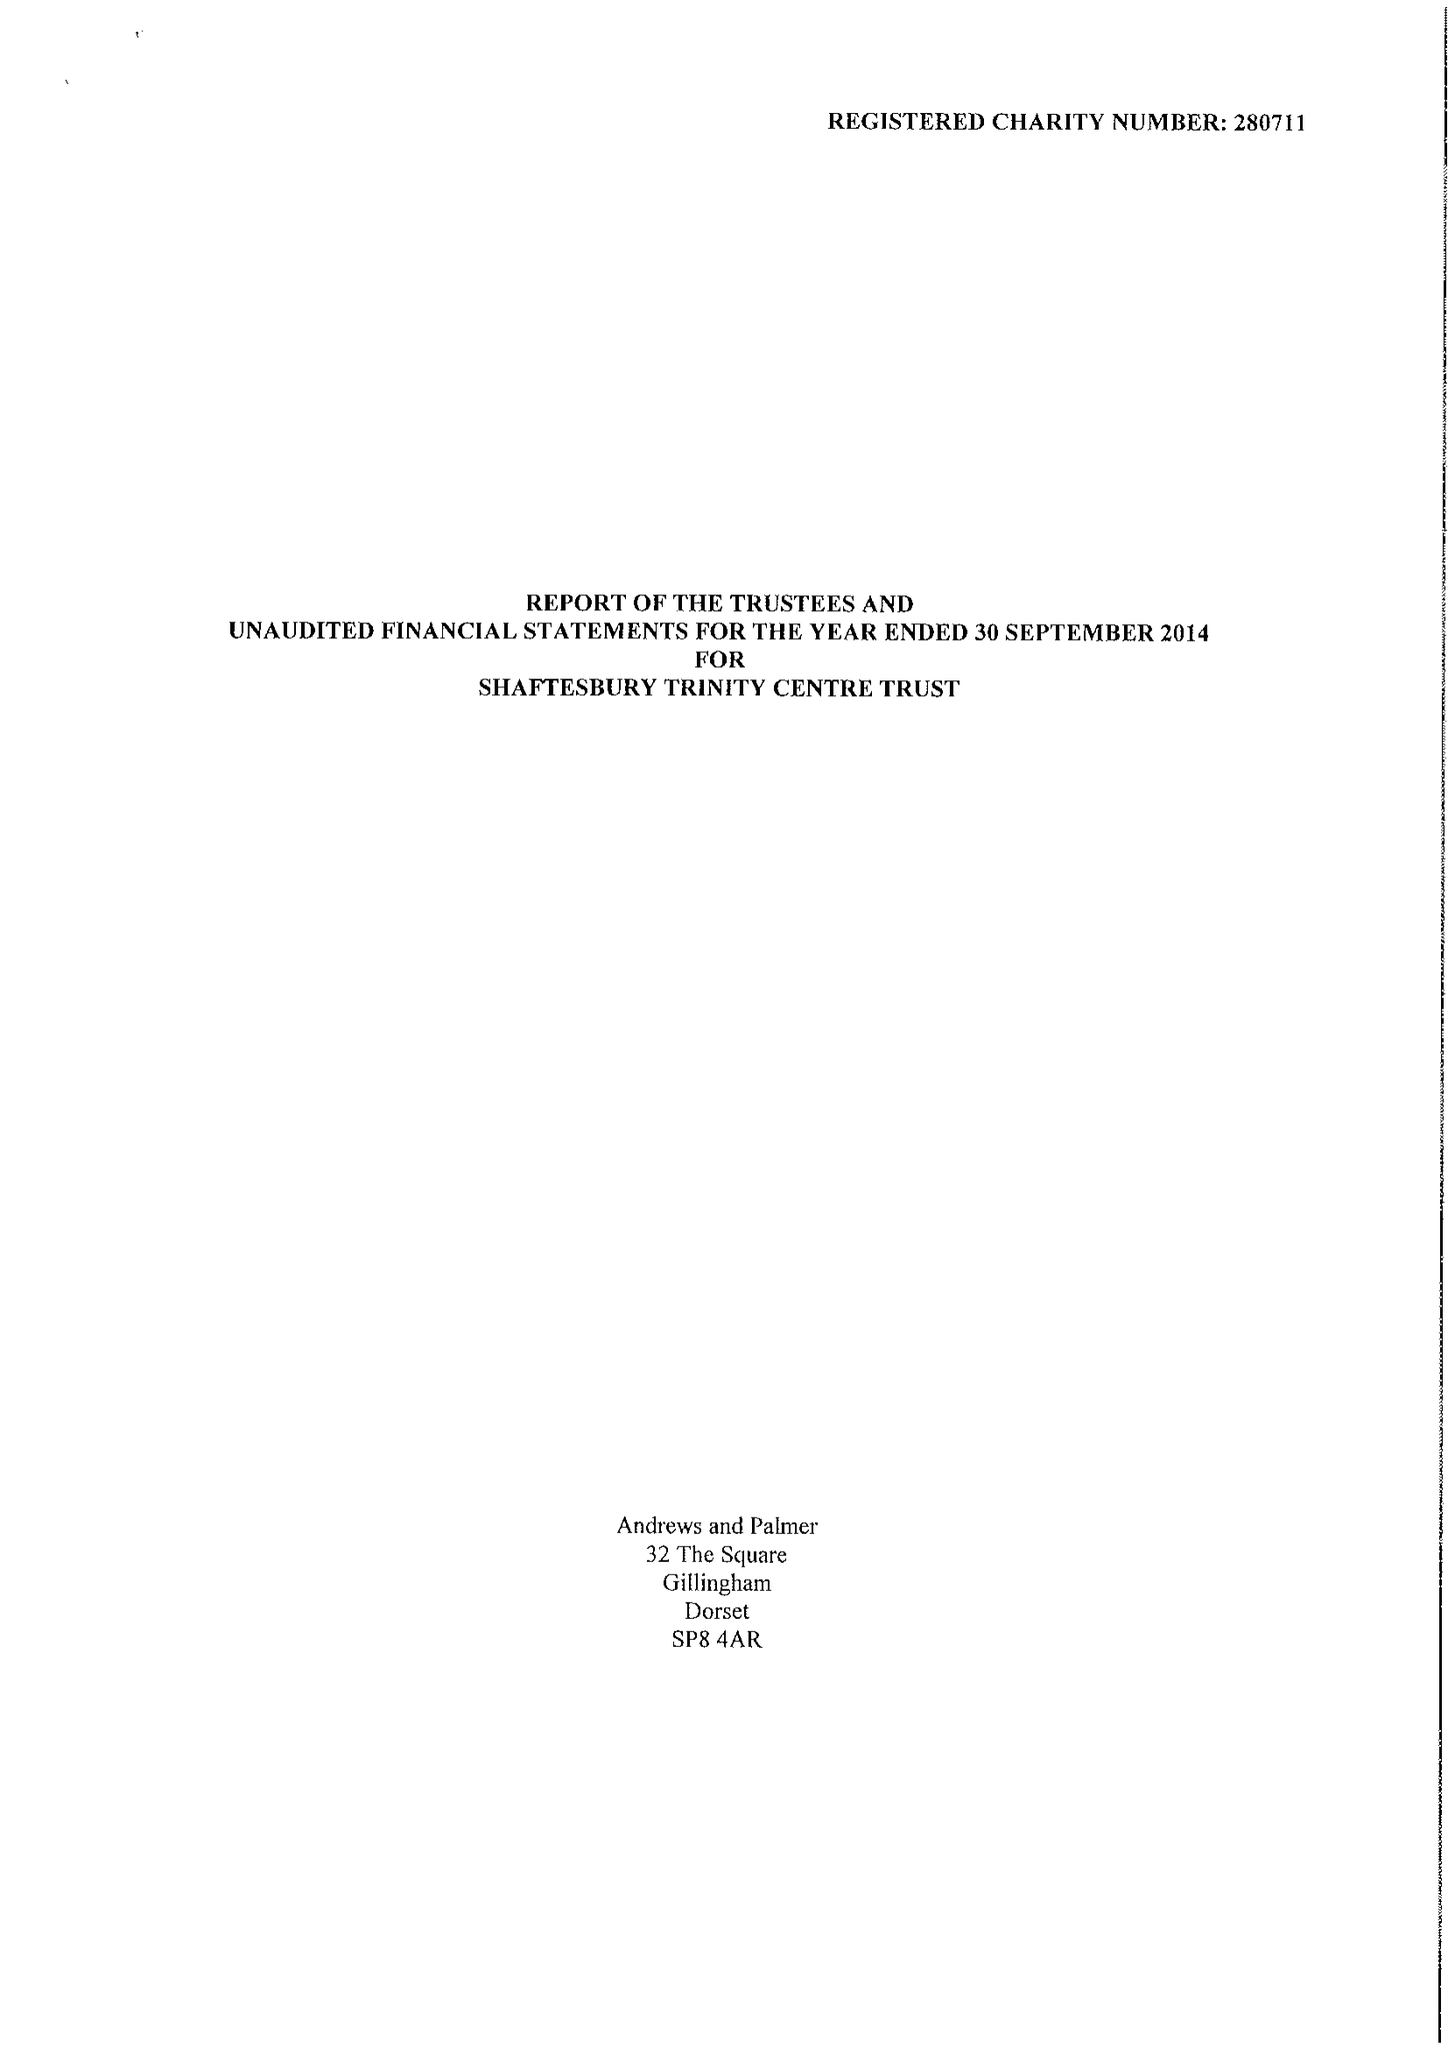What is the value for the charity_name?
Answer the question using a single word or phrase. Shaftesbury Trinity Centre Trust 